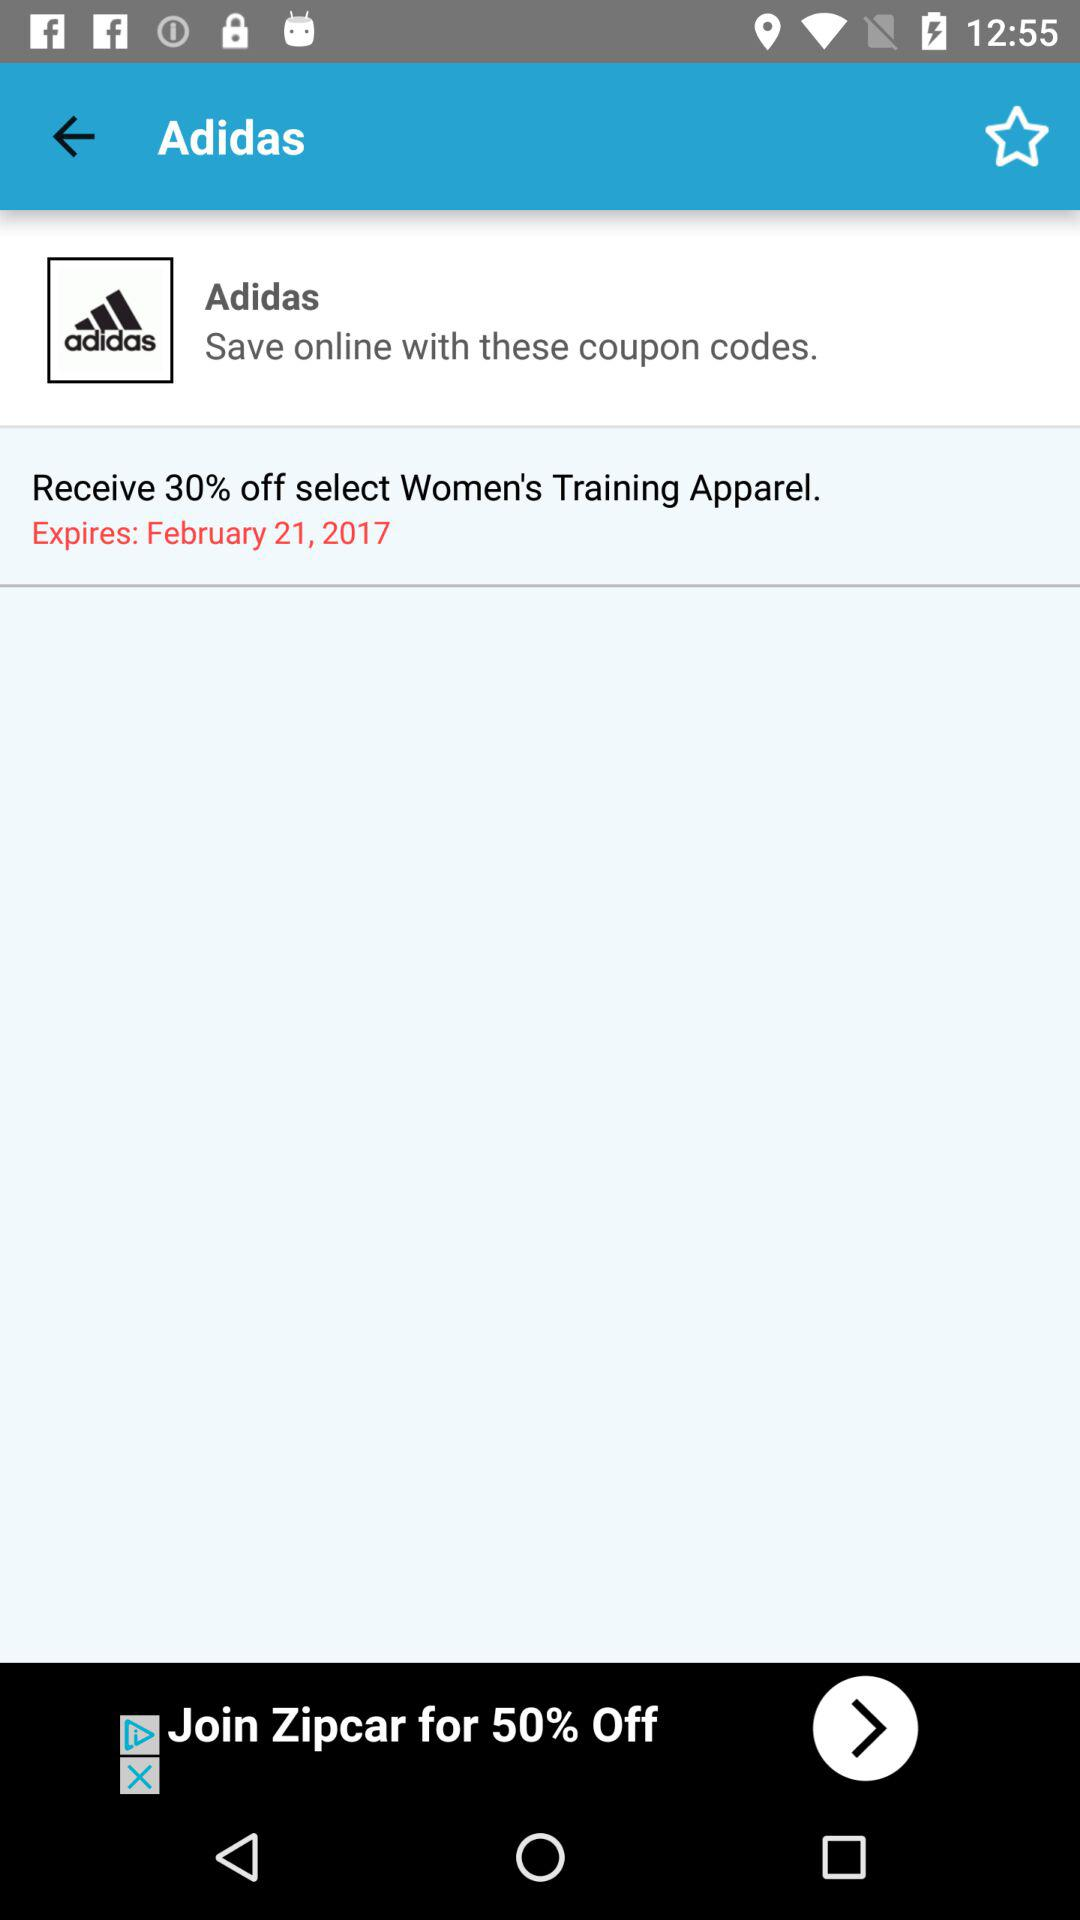What is the percentage off of the coupon code?
Answer the question using a single word or phrase. 30% 